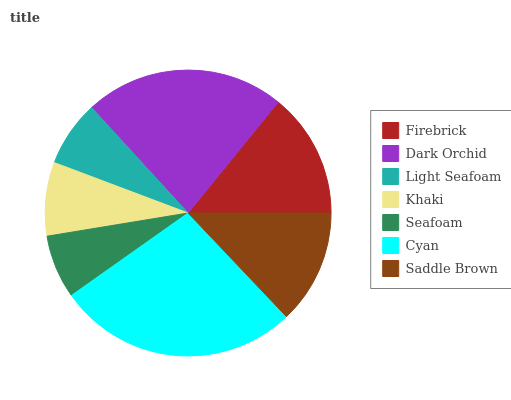Is Seafoam the minimum?
Answer yes or no. Yes. Is Cyan the maximum?
Answer yes or no. Yes. Is Dark Orchid the minimum?
Answer yes or no. No. Is Dark Orchid the maximum?
Answer yes or no. No. Is Dark Orchid greater than Firebrick?
Answer yes or no. Yes. Is Firebrick less than Dark Orchid?
Answer yes or no. Yes. Is Firebrick greater than Dark Orchid?
Answer yes or no. No. Is Dark Orchid less than Firebrick?
Answer yes or no. No. Is Saddle Brown the high median?
Answer yes or no. Yes. Is Saddle Brown the low median?
Answer yes or no. Yes. Is Cyan the high median?
Answer yes or no. No. Is Seafoam the low median?
Answer yes or no. No. 